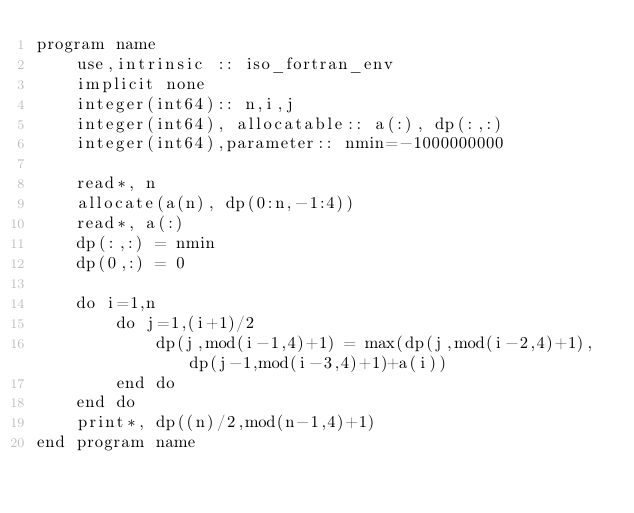Convert code to text. <code><loc_0><loc_0><loc_500><loc_500><_FORTRAN_>program name
    use,intrinsic :: iso_fortran_env
    implicit none
    integer(int64):: n,i,j
    integer(int64), allocatable:: a(:), dp(:,:)
    integer(int64),parameter:: nmin=-1000000000

    read*, n
    allocate(a(n), dp(0:n,-1:4))
    read*, a(:)
    dp(:,:) = nmin
    dp(0,:) = 0

    do i=1,n
        do j=1,(i+1)/2
            dp(j,mod(i-1,4)+1) = max(dp(j,mod(i-2,4)+1),dp(j-1,mod(i-3,4)+1)+a(i))
        end do
    end do
    print*, dp((n)/2,mod(n-1,4)+1)
end program name</code> 